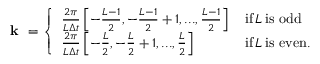Convert formula to latex. <formula><loc_0><loc_0><loc_500><loc_500>\begin{array} { r } { k = \left \{ \begin{array} { l l } { \frac { 2 \pi } { L \Delta t } \left [ - \frac { L - 1 } { 2 } , - \frac { L - 1 } { 2 } + 1 , \dots , \frac { L - 1 } { 2 } \right ] \, } & { i f \, L \, i s o d d } \\ { \frac { 2 \pi } { L \Delta t } \left [ - \frac { L } { 2 } , - \frac { L } { 2 } + 1 , \dots , \frac { L } { 2 } \right ] \, } & { i f \, L \, i s e v e n . } \end{array} } \end{array}</formula> 